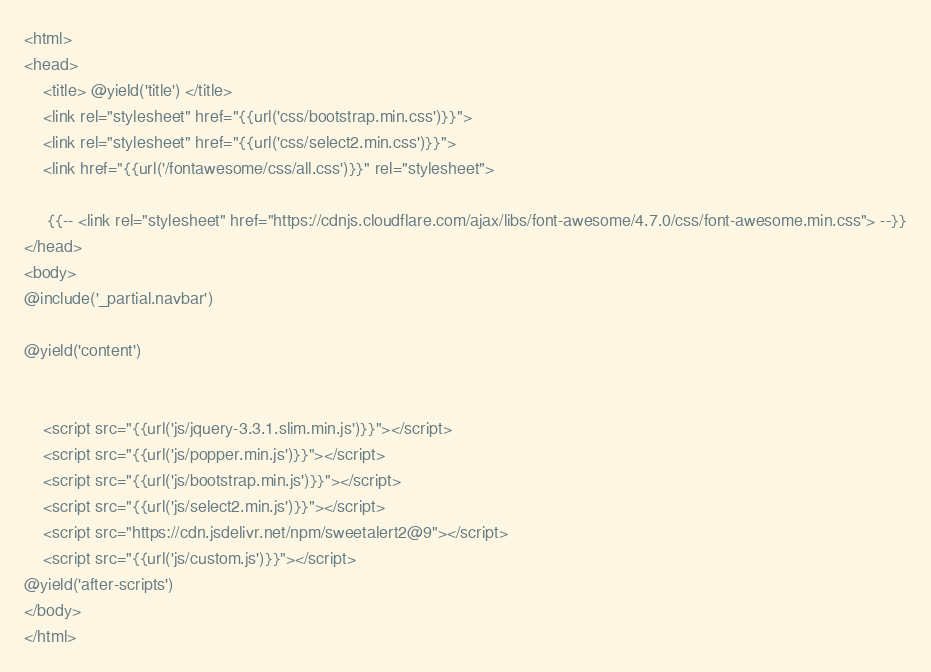<code> <loc_0><loc_0><loc_500><loc_500><_PHP_><html>
<head>
    <title> @yield('title') </title>
    <link rel="stylesheet" href="{{url('css/bootstrap.min.css')}}">
    <link rel="stylesheet" href="{{url('css/select2.min.css')}}">
    <link href="{{url('/fontawesome/css/all.css')}}" rel="stylesheet">
    
     {{-- <link rel="stylesheet" href="https://cdnjs.cloudflare.com/ajax/libs/font-awesome/4.7.0/css/font-awesome.min.css"> --}}
</head>
<body>
@include('_partial.navbar')

@yield('content')


    <script src="{{url('js/jquery-3.3.1.slim.min.js')}}"></script>
    <script src="{{url('js/popper.min.js')}}"></script>
    <script src="{{url('js/bootstrap.min.js')}}"></script>  
    <script src="{{url('js/select2.min.js')}}"></script>
    <script src="https://cdn.jsdelivr.net/npm/sweetalert2@9"></script>
    <script src="{{url('js/custom.js')}}"></script>
@yield('after-scripts')
</body>
</html></code> 